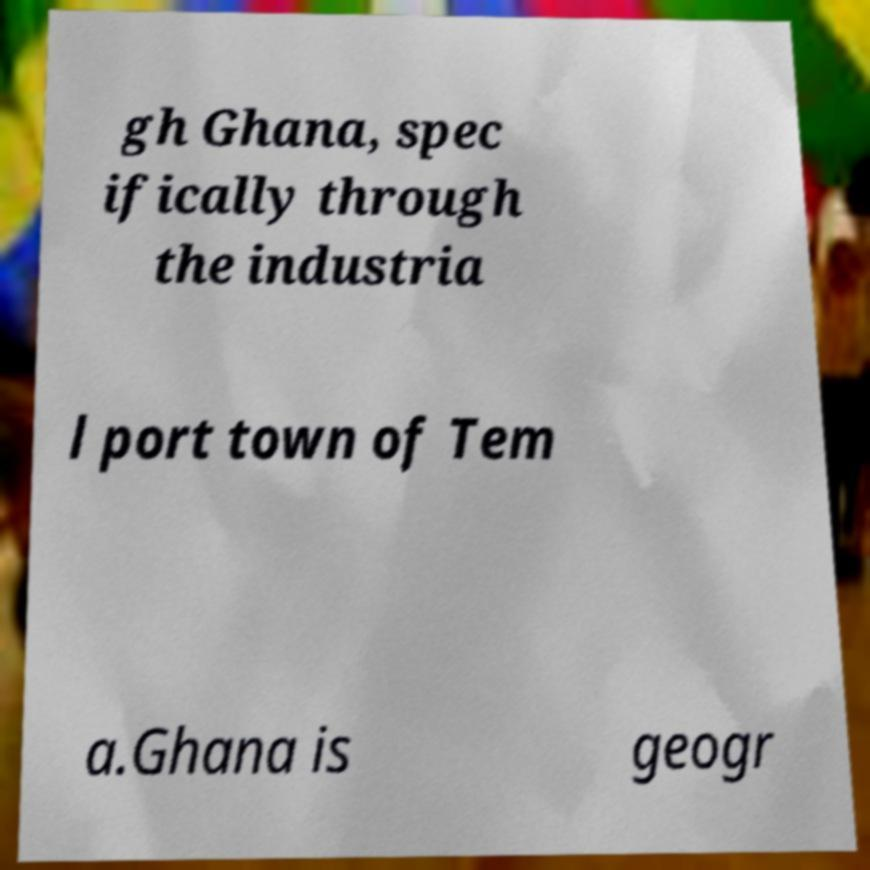For documentation purposes, I need the text within this image transcribed. Could you provide that? gh Ghana, spec ifically through the industria l port town of Tem a.Ghana is geogr 